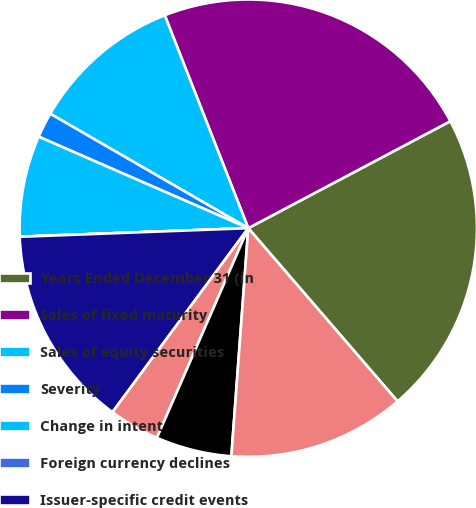Convert chart to OTSL. <chart><loc_0><loc_0><loc_500><loc_500><pie_chart><fcel>Years Ended December 31 (in<fcel>Sales of fixed maturity<fcel>Sales of equity securities<fcel>Severity<fcel>Change in intent<fcel>Foreign currency declines<fcel>Issuer-specific credit events<fcel>Adverse projected cash flows<fcel>Provision for loan losses<fcel>Foreign exchange transactions<nl><fcel>21.42%<fcel>23.2%<fcel>10.71%<fcel>1.79%<fcel>7.14%<fcel>0.01%<fcel>14.28%<fcel>3.58%<fcel>5.36%<fcel>12.5%<nl></chart> 